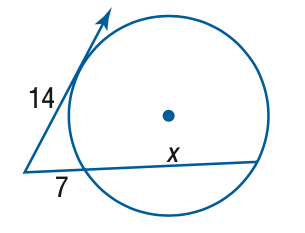Question: Find x. Assume that segments that appear to be tangent are tangent.
Choices:
A. 14
B. 21
C. 28
D. 35
Answer with the letter. Answer: B 